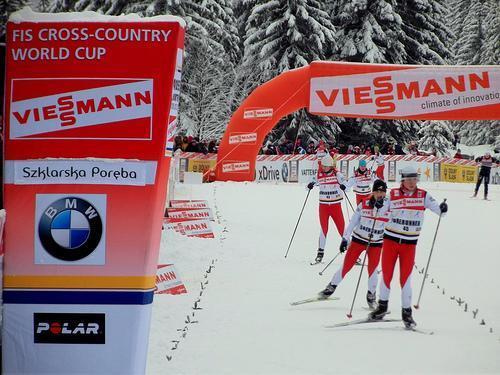How many skiers are on the track?
Give a very brief answer. 4. How many signs have the bmw logo?
Give a very brief answer. 2. 